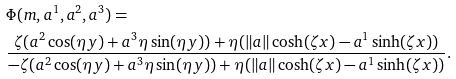<formula> <loc_0><loc_0><loc_500><loc_500>& \Phi ( m , a ^ { 1 } , a ^ { 2 } , a ^ { 3 } ) = \\ & \frac { \zeta ( a ^ { 2 } \cos ( \eta y ) + a ^ { 3 } { \eta } \sin ( \eta y ) ) + \eta ( \| a \| \cosh ( \zeta x ) - a ^ { 1 } \sinh ( \zeta x ) ) } { - \zeta ( a ^ { 2 } \cos ( \eta y ) + a ^ { 3 } { \eta } \sin ( \eta y ) ) + \eta ( \| a \| \cosh ( \zeta x ) - a ^ { 1 } \sinh ( \zeta x ) ) } .</formula> 